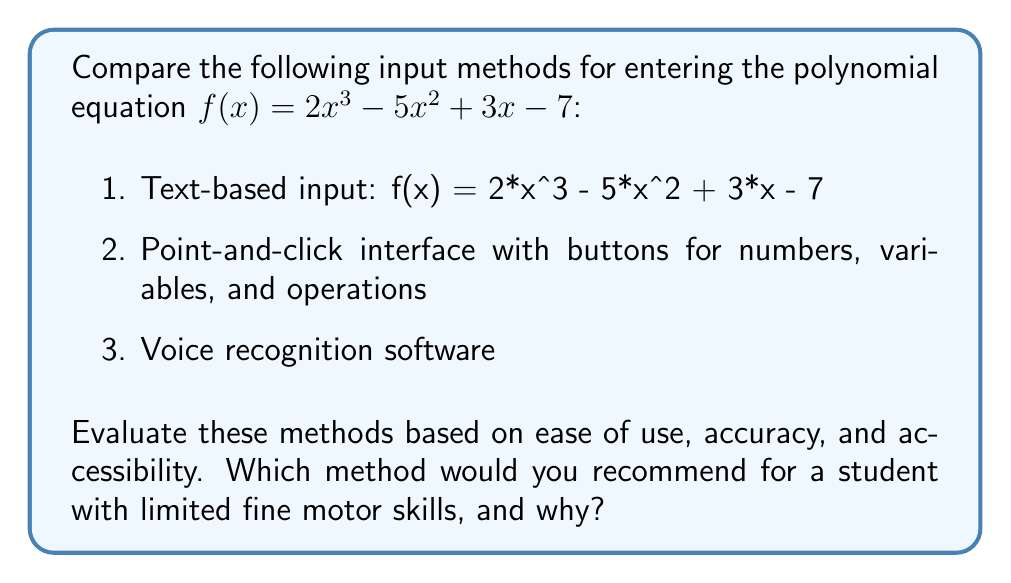Give your solution to this math problem. To evaluate the input methods for entering polynomial equations, we need to consider the following factors for each method:

1. Text-based input:
   - Ease of use: Requires typing skills and knowledge of syntax
   - Accuracy: Prone to typographical errors
   - Accessibility: May be challenging for users with limited fine motor skills

2. Point-and-click interface:
   - Ease of use: Intuitive for most users, doesn't require memorizing syntax
   - Accuracy: Less prone to errors as options are predefined
   - Accessibility: Better for users with limited fine motor skills, but may still require precise mouse control

3. Voice recognition software:
   - Ease of use: Natural language input, potentially very easy to use
   - Accuracy: Depends on the software's recognition capabilities and user's speech clarity
   - Accessibility: Excellent for users with limited fine motor skills

For a student with limited fine motor skills:

The voice recognition software would likely be the most suitable option. It eliminates the need for precise physical movements required by typing or using a mouse. This method allows the student to input equations verbally, which can be much easier and more efficient for those with motor skill limitations.

However, it's important to note that the effectiveness of voice recognition software depends on the quality of the software and the user's ability to speak clearly. Some considerations for implementation include:

1. Training the software to recognize mathematical terms and symbols
2. Providing clear feedback so the user can verify the input
3. Offering a correction mechanism for misrecognized inputs

While the point-and-click interface could be a good alternative, it may still present challenges for users with limited fine motor skills, depending on the severity of their condition. The text-based input would likely be the least accessible option for this particular user group.
Answer: The recommended input method for a student with limited fine motor skills is voice recognition software. This method offers the highest level of accessibility by eliminating the need for precise physical movements, allowing the student to input polynomial equations verbally. However, the effectiveness depends on the quality of the software and the user's ability to speak clearly. 